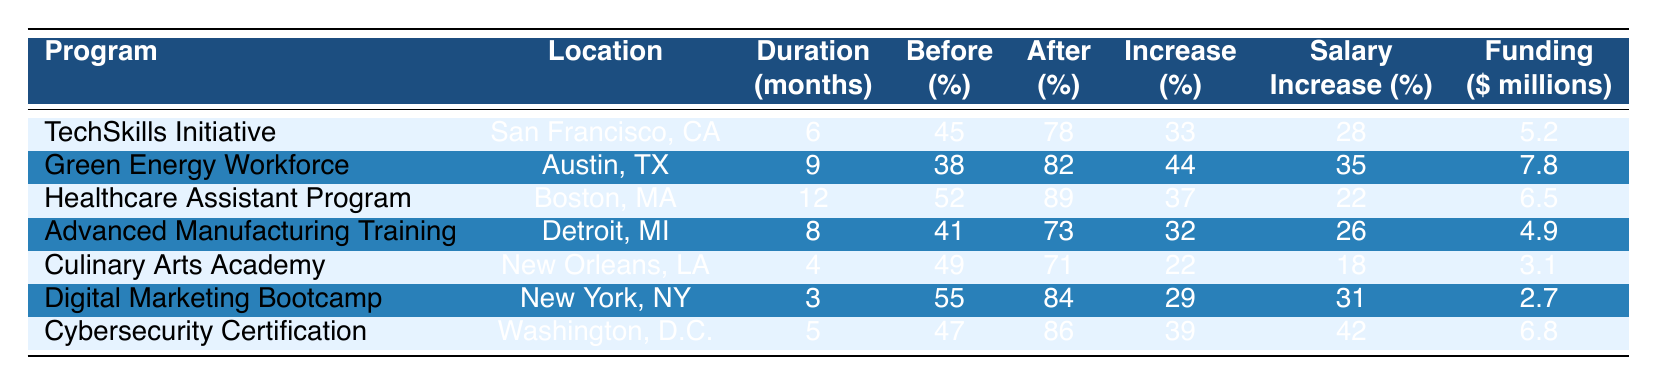What is the employment rate before the TechSkills Initiative? The employment rate before the TechSkills Initiative is directly listed in the table under the "Employment Rate Before (%)" column, which shows 45%.
Answer: 45% Which program had the highest employment rate increase? By comparing the "Increase in Employment (%)" column, the Green Energy Workforce program has the highest increase at 44%.
Answer: Green Energy Workforce How long was the Healthcare Assistant Program? The duration for the Healthcare Assistant Program is specified in the "Duration (months)" column as 12 months.
Answer: 12 months Is the average salary increase for the Cybersecurity Certification program more than 40%? The salary increase for the Cybersecurity Certification program is listed as 42%. Since 42% is greater than 40%, the answer is yes.
Answer: Yes What is the average increase in employment across all programs? First, we sum the "Increase in Employment (%)" values: 33 + 44 + 37 + 32 + 22 + 29 + 39 = 234. Since there are 7 programs, we calculate the average by dividing the sum by 7, which gives us 234/7 = 33.43%.
Answer: 33.43% How much government funding was allocated to the Culinary Arts Academy? The funding amount for the Culinary Arts Academy is directly mentioned in the "Government Funding ($ millions)" column as 3.1 million dollars.
Answer: 3.1 million dollars Which program had the lowest employment rate after completion? By examining the "Employment Rate After (%)" column, the Culinary Arts Academy shows the lowest employment rate of 71%.
Answer: Culinary Arts Academy If we consider only the programs located in major cities (NY, DC, SF), which program has the highest average salary increase? The relevant programs are TechSkills Initiative, Digital Marketing Bootcamp, and Cybersecurity Certification. Their salary increases are 28%, 31%, and 42%, respectively. The highest is the Cybersecurity Certification at 42%.
Answer: Cybersecurity Certification Is it true that the Advanced Manufacturing Training program has a higher employment rate after completion than the Culinary Arts Academy? The employment rate after the Advanced Manufacturing Training is 73%, while the Culinary Arts Academy has 71%. Since 73% is greater than 71%, the statement is true.
Answer: True 